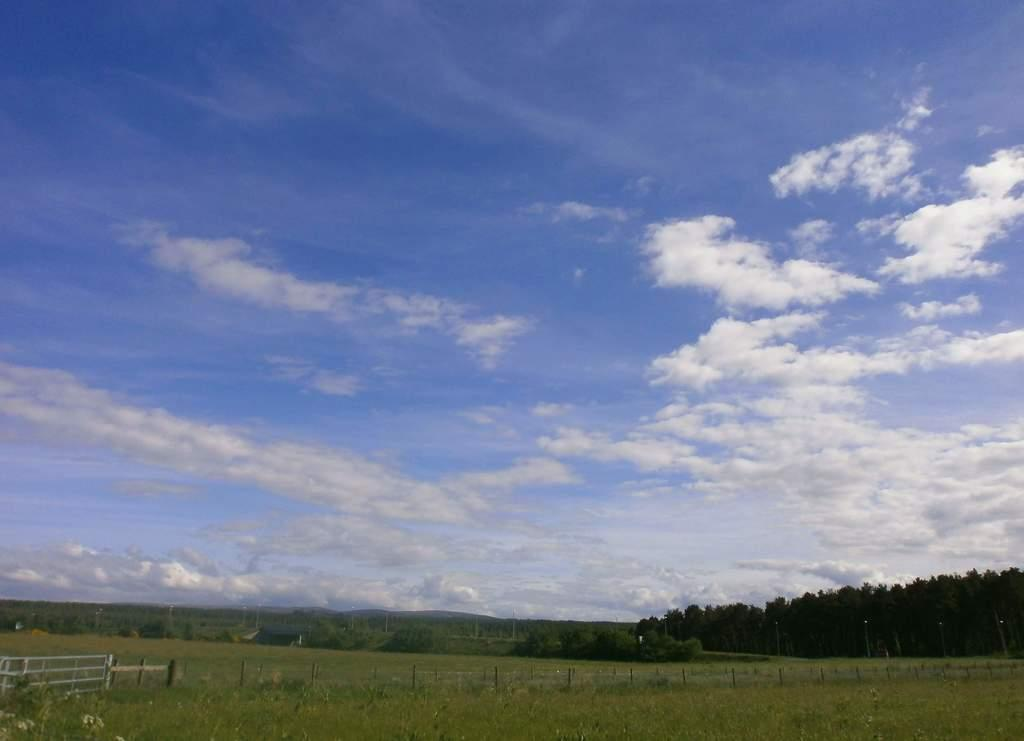What type of living organisms can be seen in the image? Plants can be seen in the image. What type of structure is present in the image? There is fencing in the image. What can be seen in the background of the image? Trees are visible in the background of the image. What is visible in the sky in the image? The sky is clear and visible in the image. What rate of growth can be observed in the plants in the image? There is no information provided about the rate of growth of the plants in the image. 